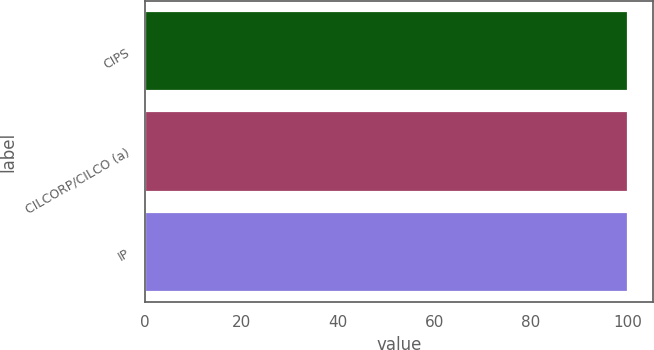Convert chart to OTSL. <chart><loc_0><loc_0><loc_500><loc_500><bar_chart><fcel>CIPS<fcel>CILCORP/CILCO (a)<fcel>IP<nl><fcel>100<fcel>100.1<fcel>100.2<nl></chart> 